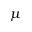Convert formula to latex. <formula><loc_0><loc_0><loc_500><loc_500>\mu</formula> 